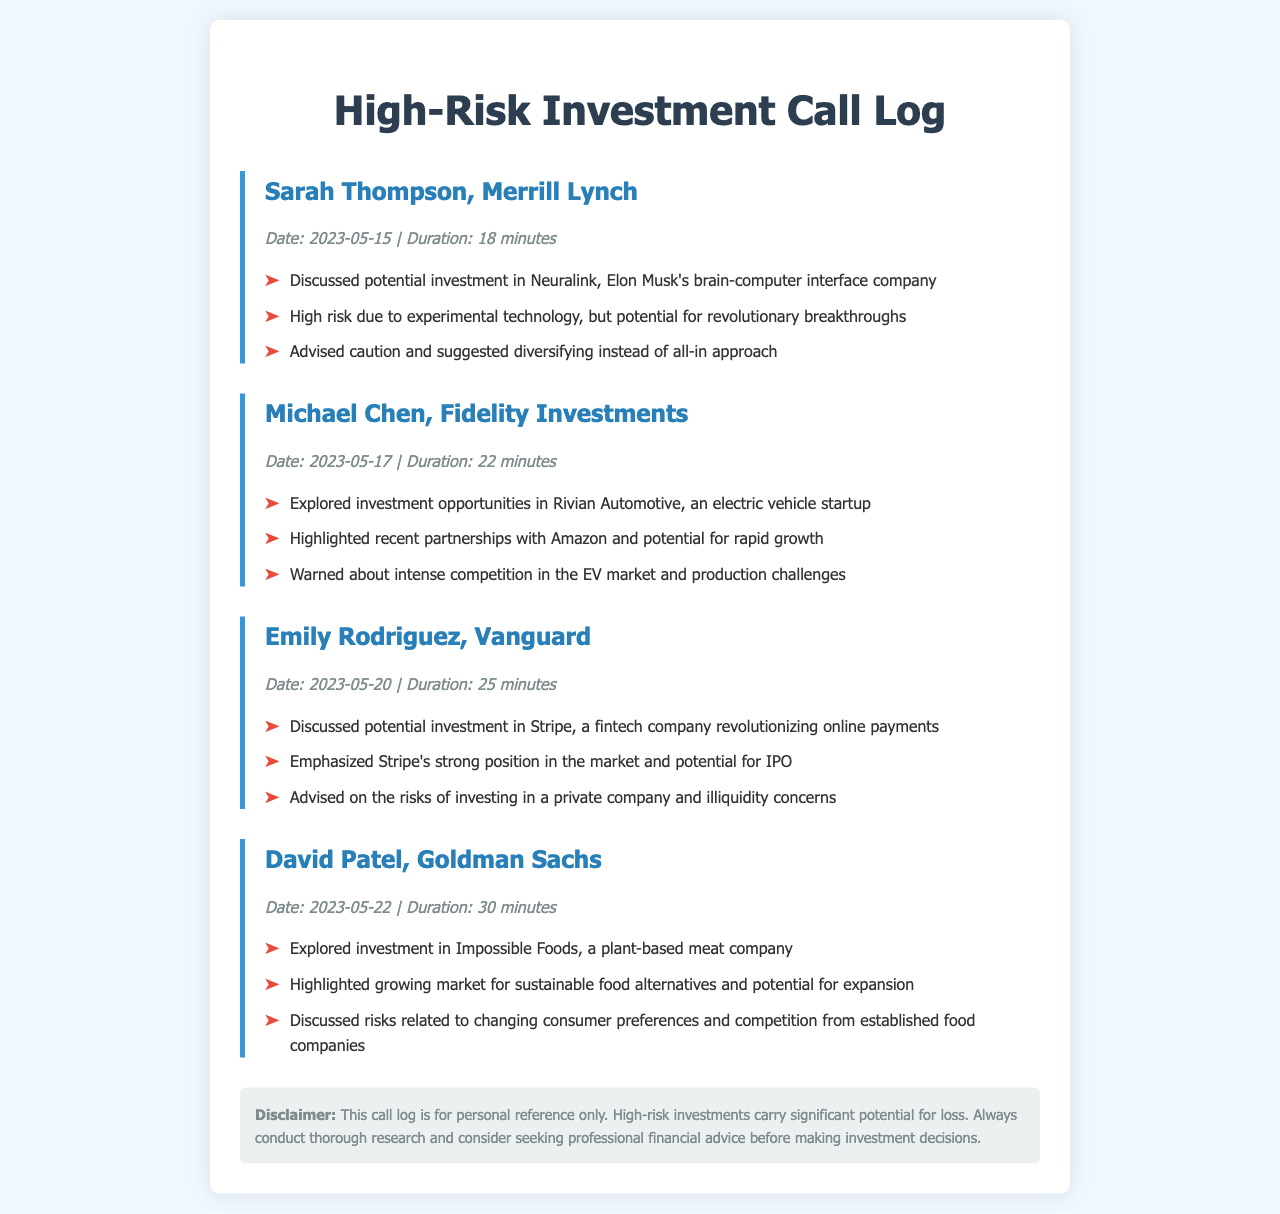what is the date of the call with Sarah Thompson? This is found in the call log entry for Sarah Thompson, which states the date of the call.
Answer: 2023-05-15 how long was the call with Michael Chen? The duration of the call with Michael Chen is stated in the call log entry.
Answer: 22 minutes which company was discussed in the call with Emily Rodriguez? The call log for Emily Rodriguez mentions the company that was discussed.
Answer: Stripe what investment opportunity was highlighted in David Patel's call? David Patel's call log specifies the investment opportunity discussed.
Answer: Impossible Foods what advice did Sarah Thompson give regarding investing? The call log entry for Sarah Thompson includes her advice on investment.
Answer: Advised caution and suggested diversifying instead of all-in approach who emphasized the potential for rapid growth in their call? The call log can be referenced to identify which financial advisor emphasized rapid growth potential.
Answer: Michael Chen which call had the longest duration? To find this, one must compare the durations listed in all the call logs.
Answer: David Patel, 30 minutes what major concern was raised in the discussion about Rivian Automotive? This concern is outlined in the details of the call log entry for Michael Chen.
Answer: Intense competition in the EV market how was the market position of Stripe described? This information is found in the call log for Emily Rodriguez.
Answer: Strong position in the market 